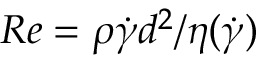Convert formula to latex. <formula><loc_0><loc_0><loc_500><loc_500>R e = \rho \dot { \gamma } d ^ { 2 } / \eta ( \dot { \gamma } )</formula> 